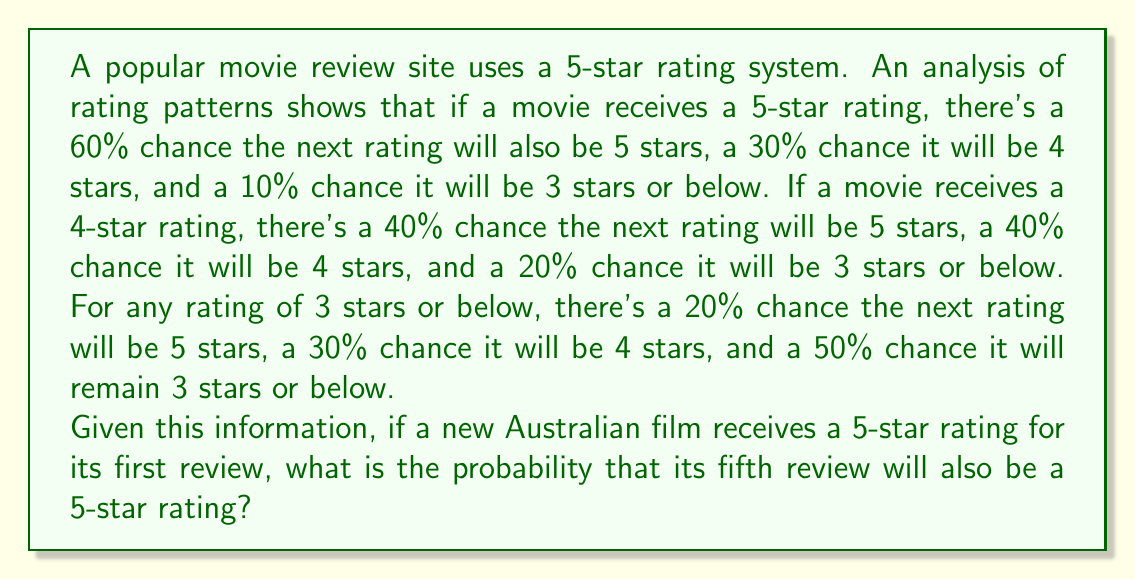Provide a solution to this math problem. Let's approach this step-by-step using Markov chains:

1) First, we need to define our transition matrix P. Based on the given information:

   $$P = \begin{bmatrix}
   0.6 & 0.3 & 0.1 \\
   0.4 & 0.4 & 0.2 \\
   0.2 & 0.3 & 0.5
   \end{bmatrix}$$

   Where the rows represent the current state (5, 4, 3 or below stars) and the columns represent the next state.

2) We're interested in the probability of being in state 5 after 4 transitions, given that we start in state 5. This can be calculated by raising the transition matrix to the 4th power and looking at the (1,1) entry.

3) To calculate $P^4$, we can use matrix multiplication:

   $$P^4 = P \cdot P \cdot P \cdot P$$

4) After performing this calculation (which can be done easily with a computer or calculator), we get:

   $$P^4 \approx \begin{bmatrix}
   0.4621 & 0.3249 & 0.2130 \\
   0.4383 & 0.3331 & 0.2286 \\
   0.3913 & 0.3247 & 0.2840
   \end{bmatrix}$$

5) The probability we're looking for is the (1,1) entry of this matrix, which is approximately 0.4621 or 46.21%.
Answer: 0.4621 (or 46.21%) 